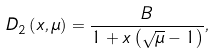<formula> <loc_0><loc_0><loc_500><loc_500>D _ { 2 } \left ( x , \mu \right ) = \frac { B } { 1 + x \left ( \sqrt { \mu } - 1 \right ) } ,</formula> 